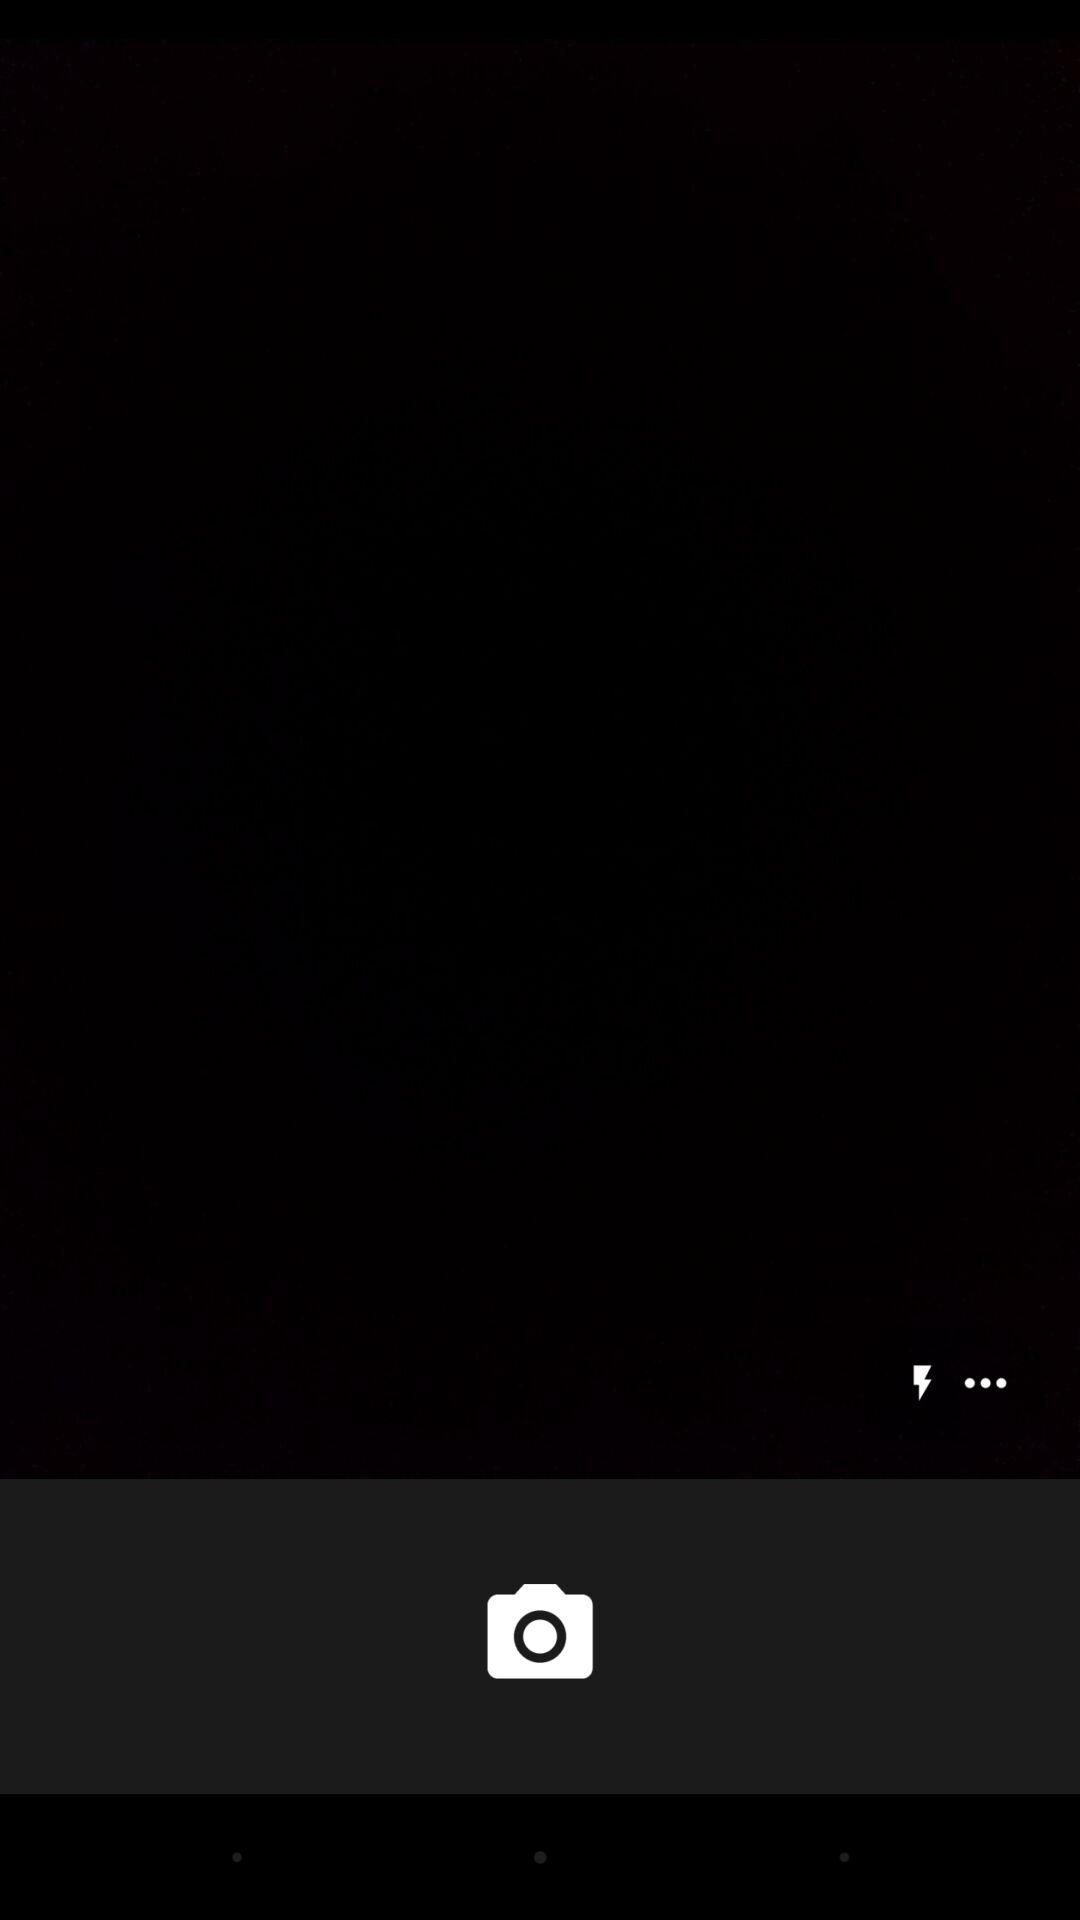How many more dots are there than lightning bolts?
Answer the question using a single word or phrase. 2 